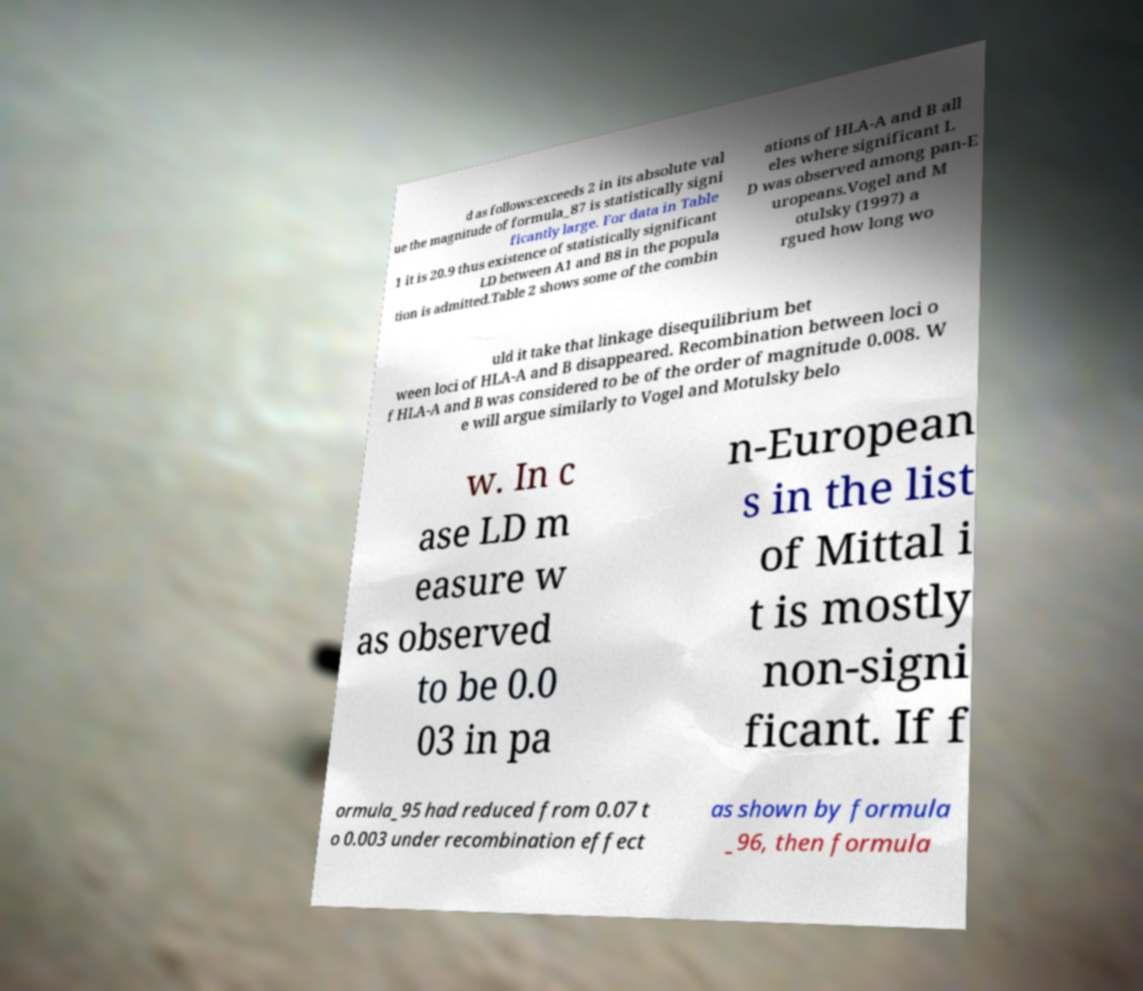For documentation purposes, I need the text within this image transcribed. Could you provide that? d as follows:exceeds 2 in its absolute val ue the magnitude of formula_87 is statistically signi ficantly large. For data in Table 1 it is 20.9 thus existence of statistically significant LD between A1 and B8 in the popula tion is admitted.Table 2 shows some of the combin ations of HLA-A and B all eles where significant L D was observed among pan-E uropeans.Vogel and M otulsky (1997) a rgued how long wo uld it take that linkage disequilibrium bet ween loci of HLA-A and B disappeared. Recombination between loci o f HLA-A and B was considered to be of the order of magnitude 0.008. W e will argue similarly to Vogel and Motulsky belo w. In c ase LD m easure w as observed to be 0.0 03 in pa n-European s in the list of Mittal i t is mostly non-signi ficant. If f ormula_95 had reduced from 0.07 t o 0.003 under recombination effect as shown by formula _96, then formula 